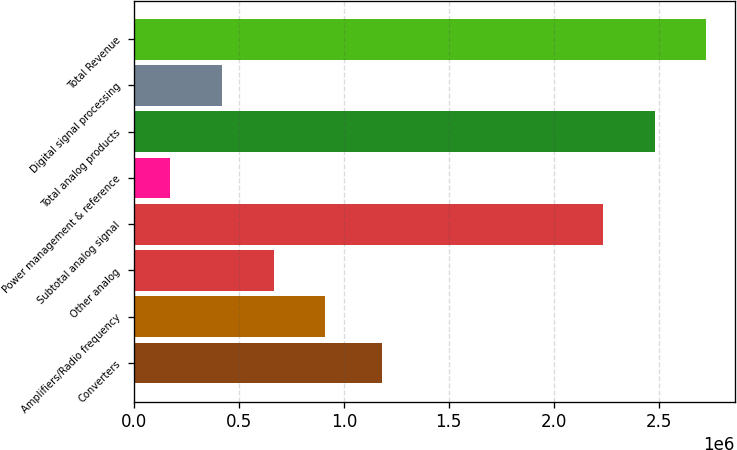Convert chart to OTSL. <chart><loc_0><loc_0><loc_500><loc_500><bar_chart><fcel>Converters<fcel>Amplifiers/Radio frequency<fcel>Other analog<fcel>Subtotal analog signal<fcel>Power management & reference<fcel>Total analog products<fcel>Digital signal processing<fcel>Total Revenue<nl><fcel>1.18007e+06<fcel>911151<fcel>665074<fcel>2.23511e+06<fcel>172920<fcel>2.48119e+06<fcel>418997<fcel>2.72727e+06<nl></chart> 